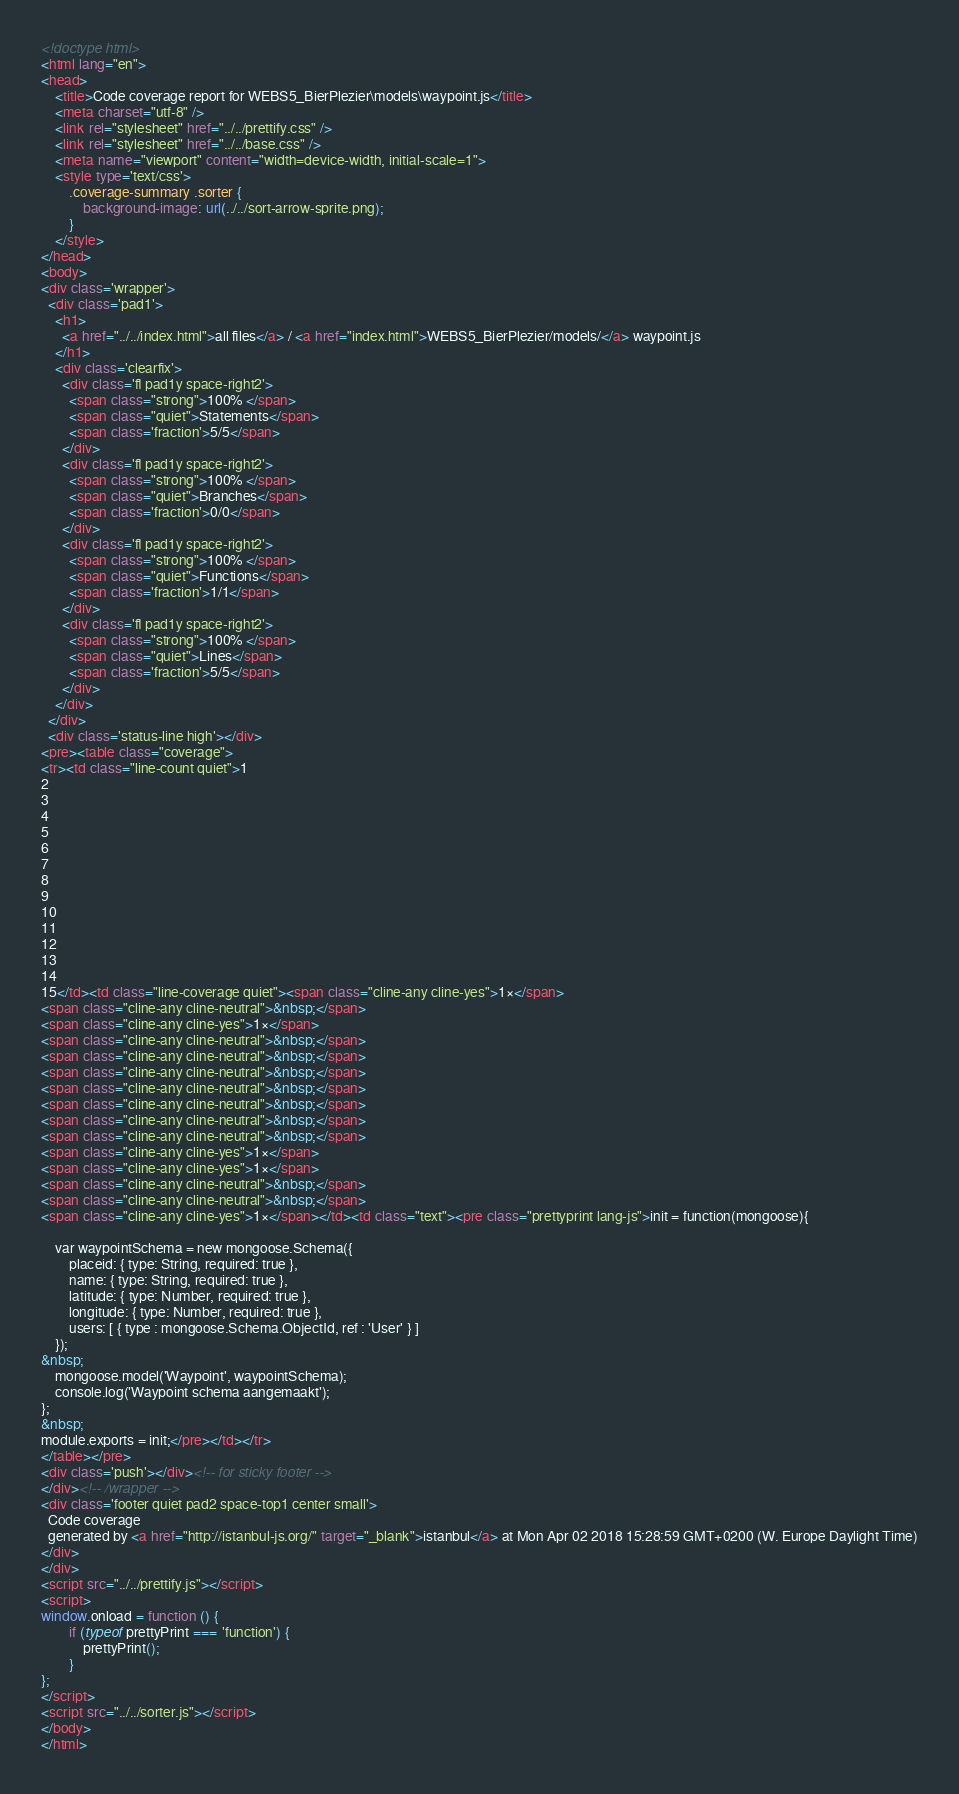Convert code to text. <code><loc_0><loc_0><loc_500><loc_500><_HTML_><!doctype html>
<html lang="en">
<head>
    <title>Code coverage report for WEBS5_BierPlezier\models\waypoint.js</title>
    <meta charset="utf-8" />
    <link rel="stylesheet" href="../../prettify.css" />
    <link rel="stylesheet" href="../../base.css" />
    <meta name="viewport" content="width=device-width, initial-scale=1">
    <style type='text/css'>
        .coverage-summary .sorter {
            background-image: url(../../sort-arrow-sprite.png);
        }
    </style>
</head>
<body>
<div class='wrapper'>
  <div class='pad1'>
    <h1>
      <a href="../../index.html">all files</a> / <a href="index.html">WEBS5_BierPlezier/models/</a> waypoint.js
    </h1>
    <div class='clearfix'>
      <div class='fl pad1y space-right2'>
        <span class="strong">100% </span>
        <span class="quiet">Statements</span>
        <span class='fraction'>5/5</span>
      </div>
      <div class='fl pad1y space-right2'>
        <span class="strong">100% </span>
        <span class="quiet">Branches</span>
        <span class='fraction'>0/0</span>
      </div>
      <div class='fl pad1y space-right2'>
        <span class="strong">100% </span>
        <span class="quiet">Functions</span>
        <span class='fraction'>1/1</span>
      </div>
      <div class='fl pad1y space-right2'>
        <span class="strong">100% </span>
        <span class="quiet">Lines</span>
        <span class='fraction'>5/5</span>
      </div>
    </div>
  </div>
  <div class='status-line high'></div>
<pre><table class="coverage">
<tr><td class="line-count quiet">1
2
3
4
5
6
7
8
9
10
11
12
13
14
15</td><td class="line-coverage quiet"><span class="cline-any cline-yes">1×</span>
<span class="cline-any cline-neutral">&nbsp;</span>
<span class="cline-any cline-yes">1×</span>
<span class="cline-any cline-neutral">&nbsp;</span>
<span class="cline-any cline-neutral">&nbsp;</span>
<span class="cline-any cline-neutral">&nbsp;</span>
<span class="cline-any cline-neutral">&nbsp;</span>
<span class="cline-any cline-neutral">&nbsp;</span>
<span class="cline-any cline-neutral">&nbsp;</span>
<span class="cline-any cline-neutral">&nbsp;</span>
<span class="cline-any cline-yes">1×</span>
<span class="cline-any cline-yes">1×</span>
<span class="cline-any cline-neutral">&nbsp;</span>
<span class="cline-any cline-neutral">&nbsp;</span>
<span class="cline-any cline-yes">1×</span></td><td class="text"><pre class="prettyprint lang-js">init = function(mongoose){
	
	var waypointSchema = new mongoose.Schema({
		placeid: { type: String, required: true },
		name: { type: String, required: true },
		latitude: { type: Number, required: true },
		longitude: { type: Number, required: true },
		users: [ { type : mongoose.Schema.ObjectId, ref : 'User' } ]
	});
&nbsp;
	mongoose.model('Waypoint', waypointSchema);
	console.log('Waypoint schema aangemaakt');
};
&nbsp;
module.exports = init;</pre></td></tr>
</table></pre>
<div class='push'></div><!-- for sticky footer -->
</div><!-- /wrapper -->
<div class='footer quiet pad2 space-top1 center small'>
  Code coverage
  generated by <a href="http://istanbul-js.org/" target="_blank">istanbul</a> at Mon Apr 02 2018 15:28:59 GMT+0200 (W. Europe Daylight Time)
</div>
</div>
<script src="../../prettify.js"></script>
<script>
window.onload = function () {
        if (typeof prettyPrint === 'function') {
            prettyPrint();
        }
};
</script>
<script src="../../sorter.js"></script>
</body>
</html>
</code> 